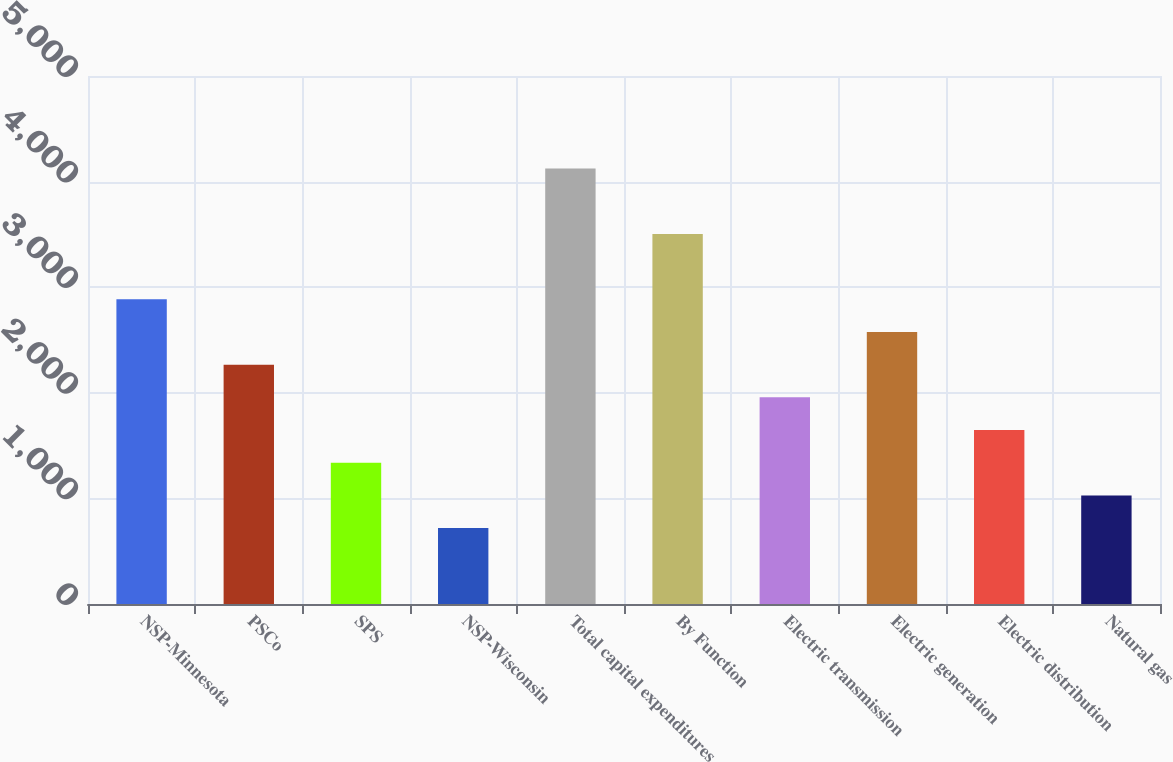Convert chart. <chart><loc_0><loc_0><loc_500><loc_500><bar_chart><fcel>NSP-Minnesota<fcel>PSCo<fcel>SPS<fcel>NSP-Wisconsin<fcel>Total capital expenditures<fcel>By Function<fcel>Electric transmission<fcel>Electric generation<fcel>Electric distribution<fcel>Natural gas<nl><fcel>2885.5<fcel>2266.5<fcel>1338<fcel>719<fcel>4123.5<fcel>3504.5<fcel>1957<fcel>2576<fcel>1647.5<fcel>1028.5<nl></chart> 